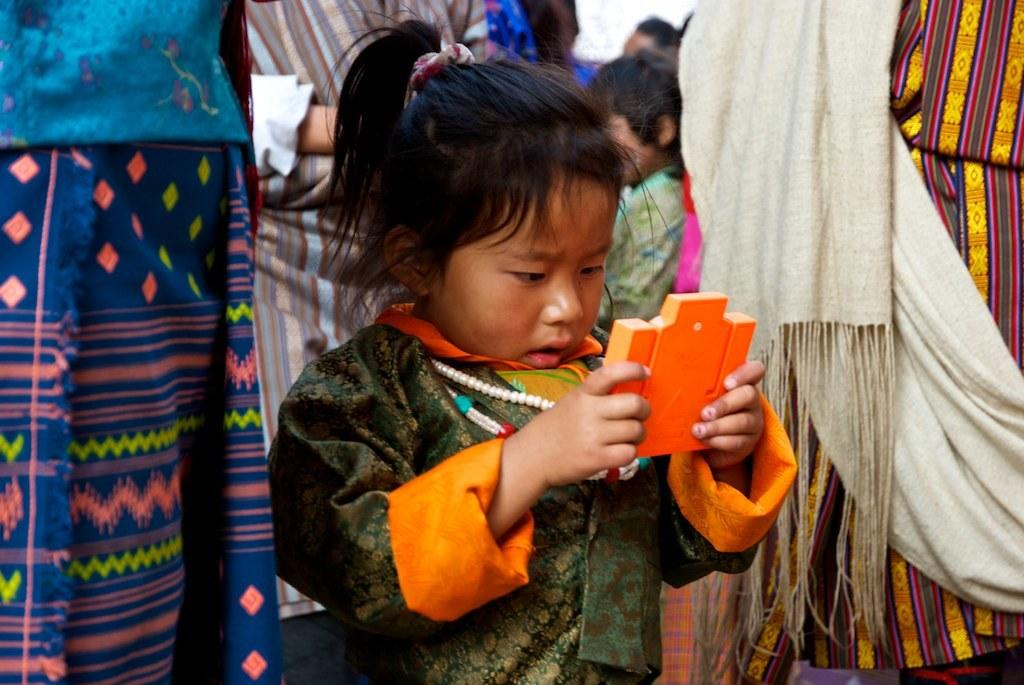Who is the main subject in the image? There is a girl in the center of the image. What is the girl doing in the image? The girl is standing in the image. What is the girl holding in the image? The girl is holding an object in the image. Can you describe the surroundings of the girl in the image? There are people in the background of the image. What type of shirt is the girl wearing in the image? The provided facts do not mention the girl's shirt, so we cannot determine the type of shirt she is wearing. 